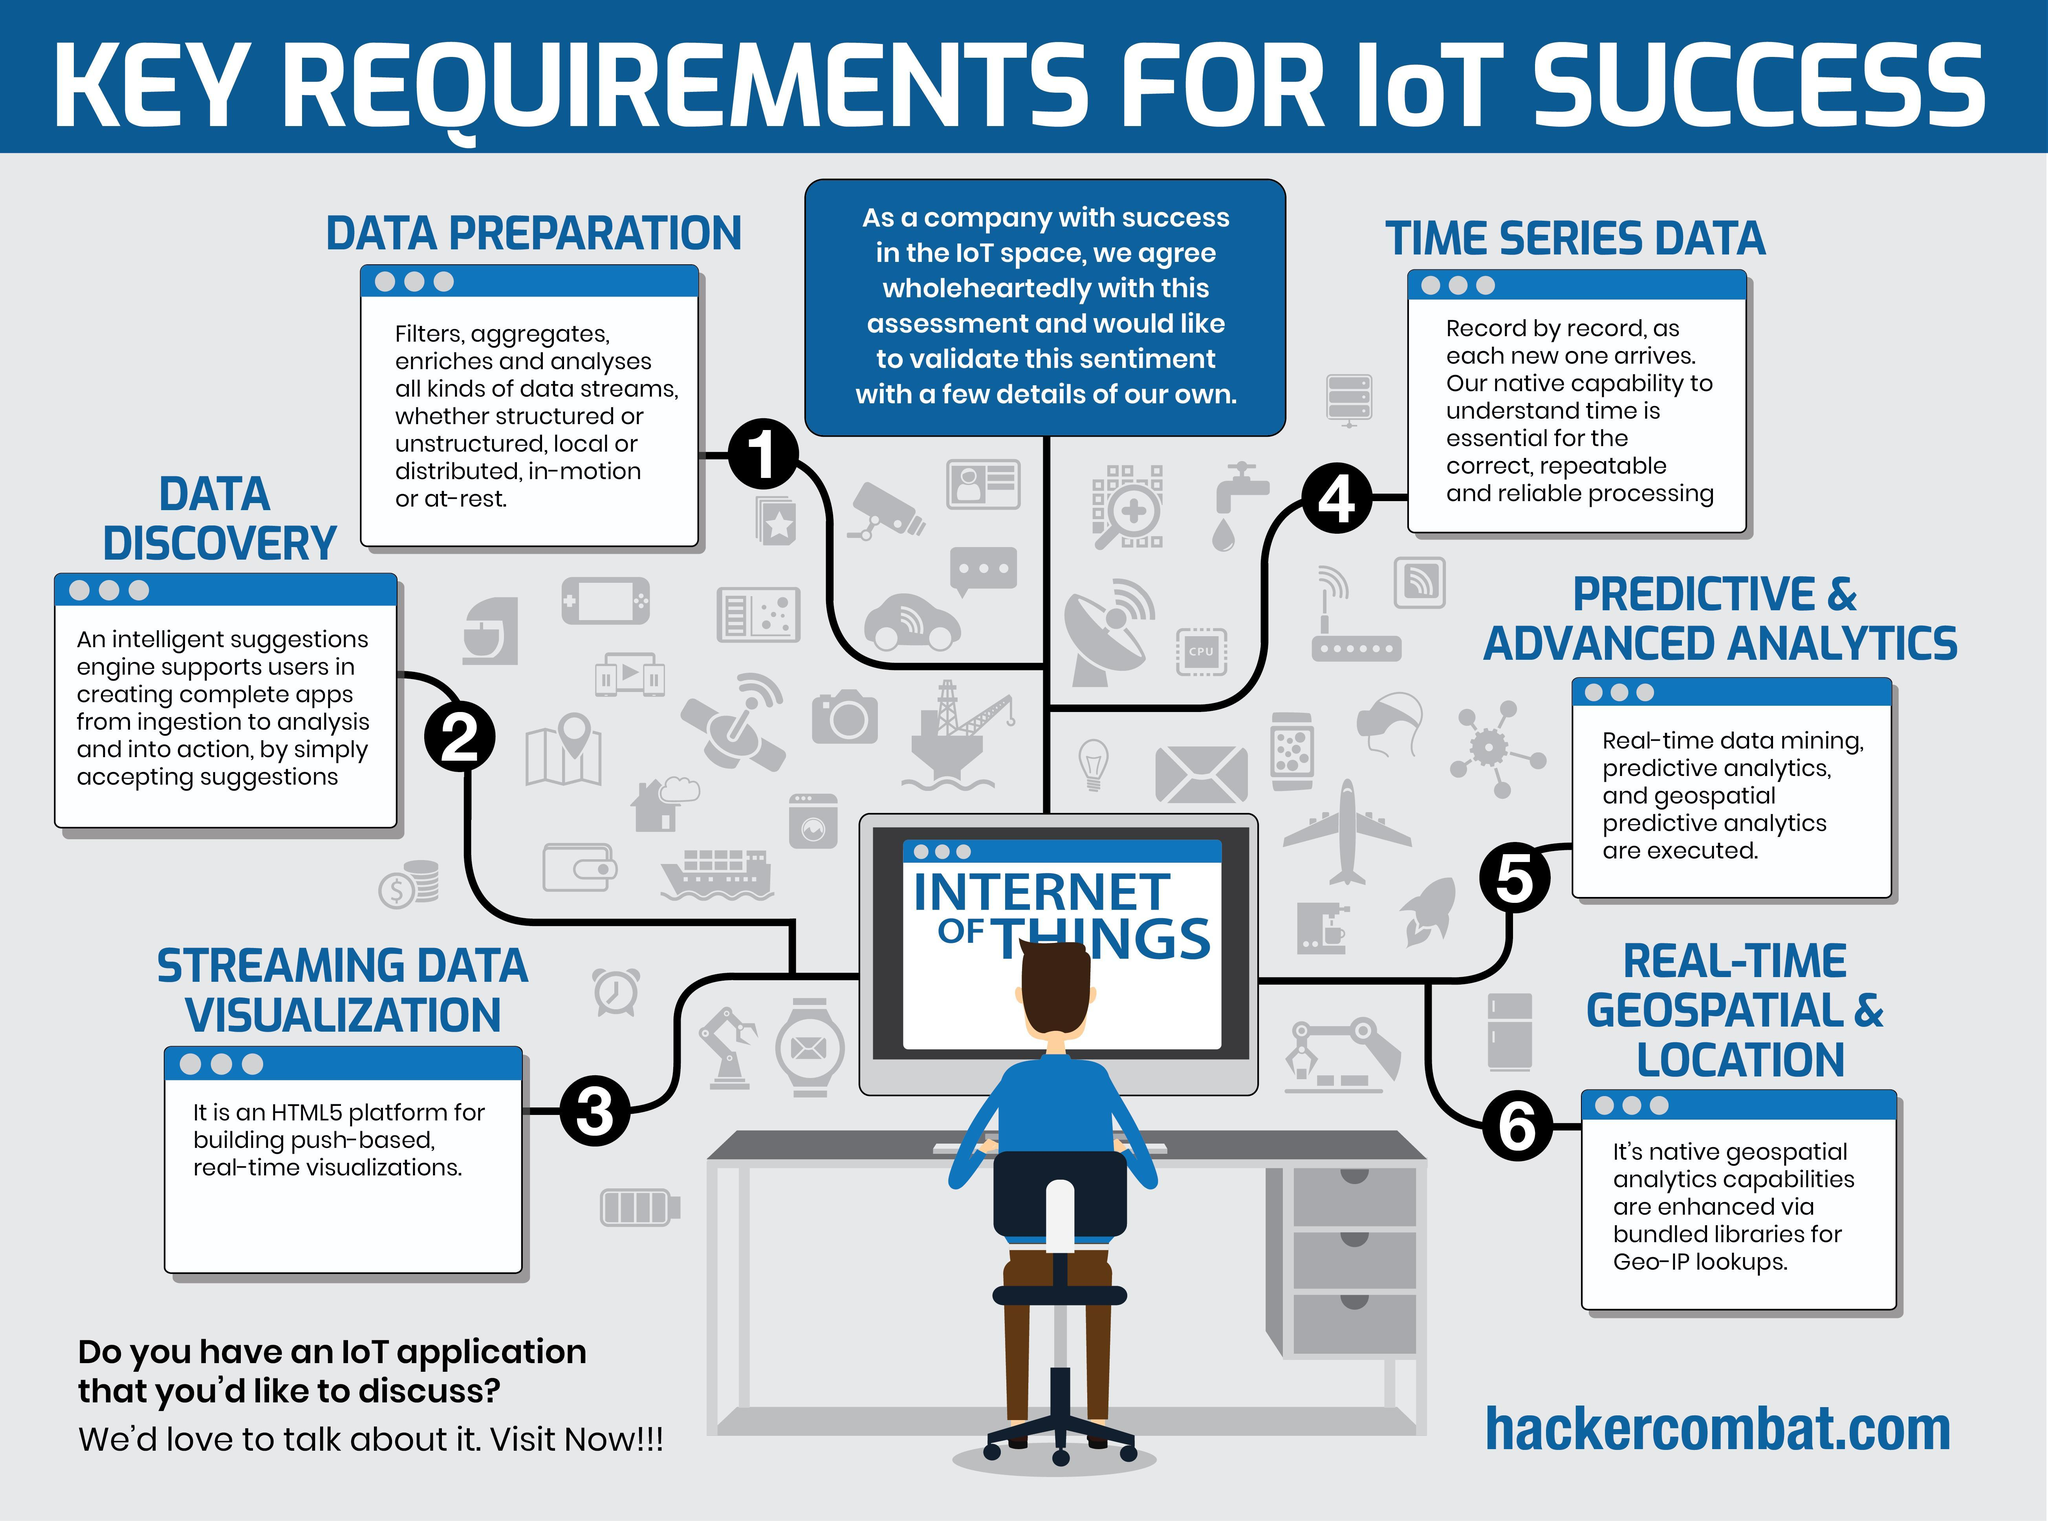How many requirements have been listed for IoT success?
Answer the question with a short phrase. 6 What color is not used in the infographic, blue, grey or green? green 